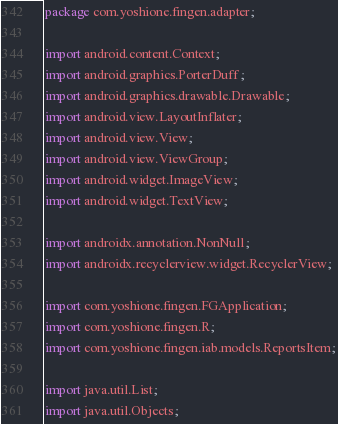Convert code to text. <code><loc_0><loc_0><loc_500><loc_500><_Java_>package com.yoshione.fingen.adapter;

import android.content.Context;
import android.graphics.PorterDuff;
import android.graphics.drawable.Drawable;
import android.view.LayoutInflater;
import android.view.View;
import android.view.ViewGroup;
import android.widget.ImageView;
import android.widget.TextView;

import androidx.annotation.NonNull;
import androidx.recyclerview.widget.RecyclerView;

import com.yoshione.fingen.FGApplication;
import com.yoshione.fingen.R;
import com.yoshione.fingen.iab.models.ReportsItem;

import java.util.List;
import java.util.Objects;
</code> 